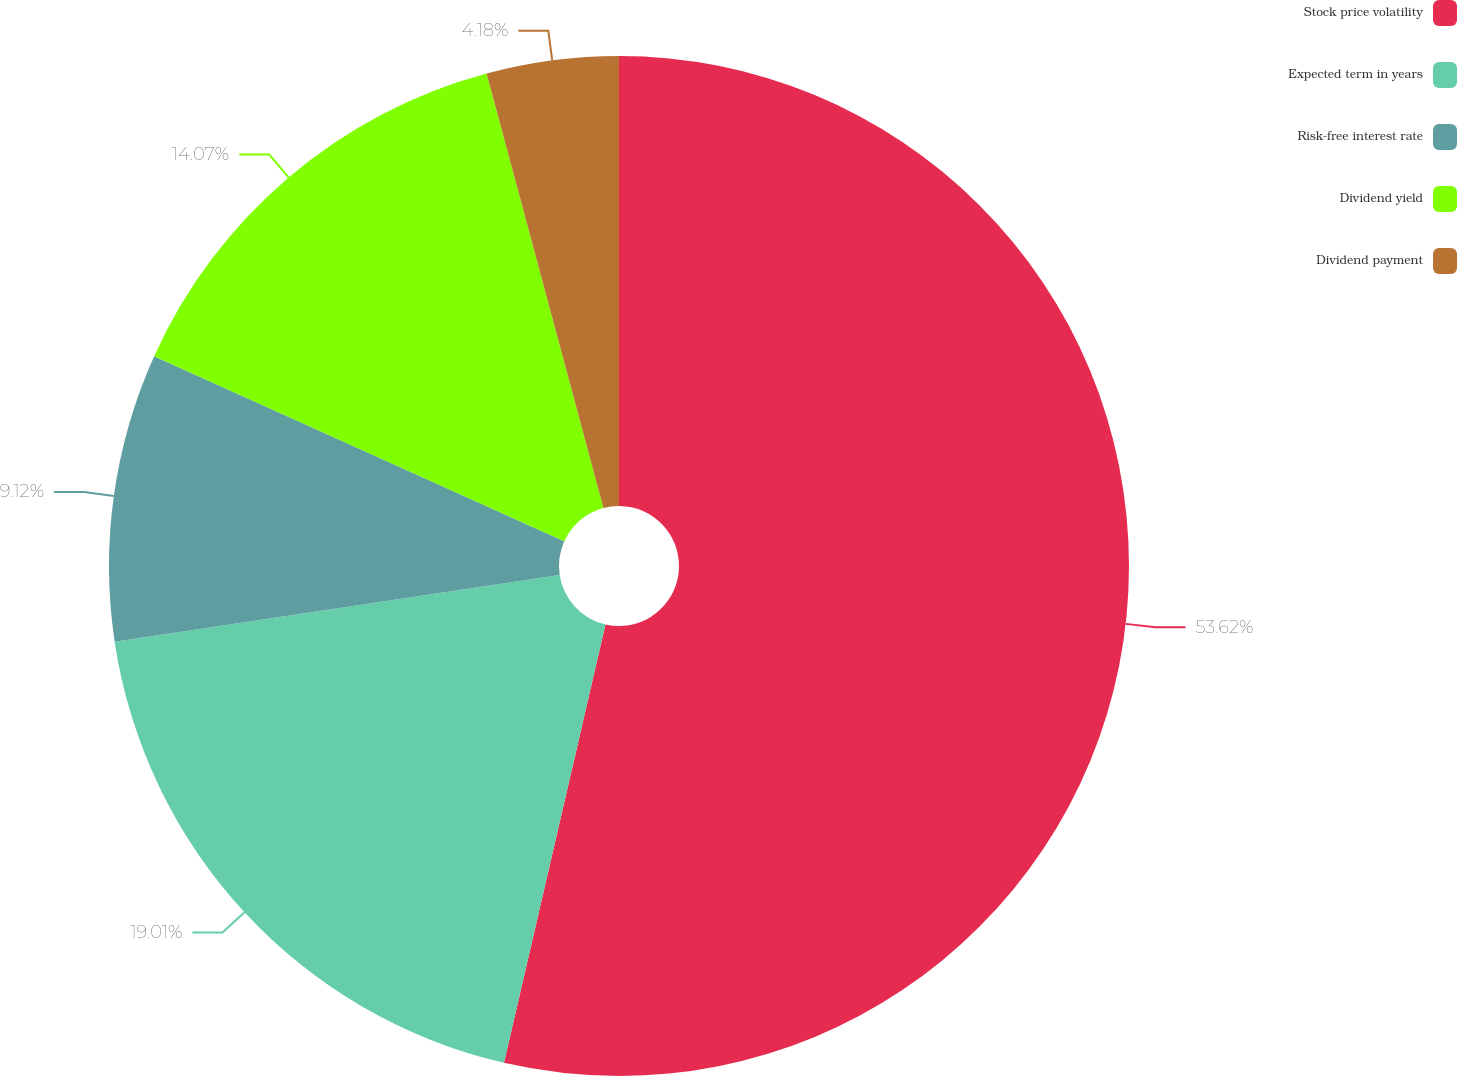Convert chart to OTSL. <chart><loc_0><loc_0><loc_500><loc_500><pie_chart><fcel>Stock price volatility<fcel>Expected term in years<fcel>Risk-free interest rate<fcel>Dividend yield<fcel>Dividend payment<nl><fcel>53.62%<fcel>19.01%<fcel>9.12%<fcel>14.07%<fcel>4.18%<nl></chart> 